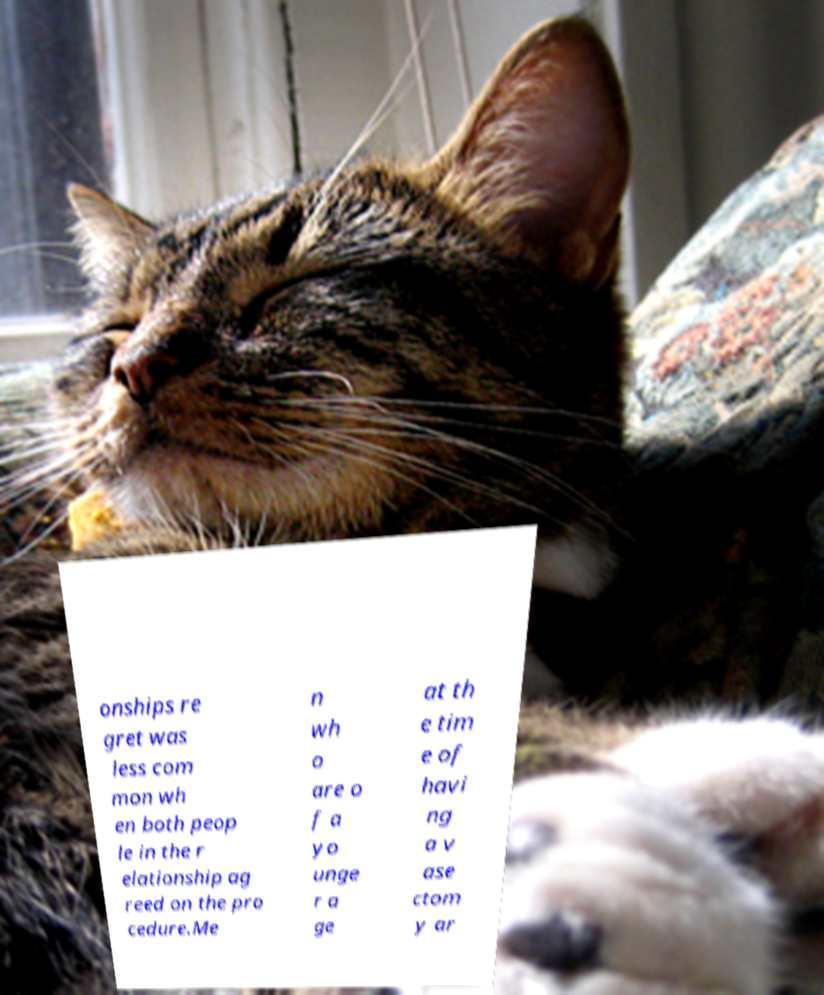Please identify and transcribe the text found in this image. onships re gret was less com mon wh en both peop le in the r elationship ag reed on the pro cedure.Me n wh o are o f a yo unge r a ge at th e tim e of havi ng a v ase ctom y ar 